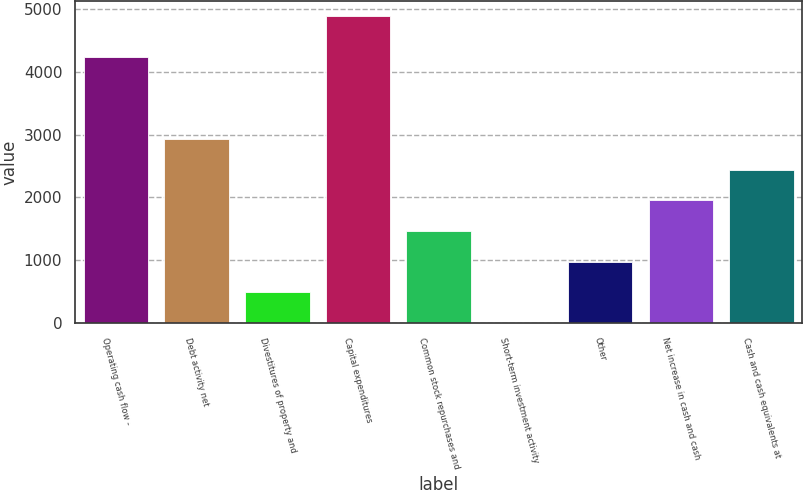Convert chart to OTSL. <chart><loc_0><loc_0><loc_500><loc_500><bar_chart><fcel>Operating cash flow -<fcel>Debt activity net<fcel>Divestitures of property and<fcel>Capital expenditures<fcel>Common stock repurchases and<fcel>Short-term investment activity<fcel>Other<fcel>Net increase in cash and cash<fcel>Cash and cash equivalents at<nl><fcel>4232<fcel>2930.2<fcel>494.2<fcel>4879<fcel>1468.6<fcel>7<fcel>981.4<fcel>1955.8<fcel>2443<nl></chart> 